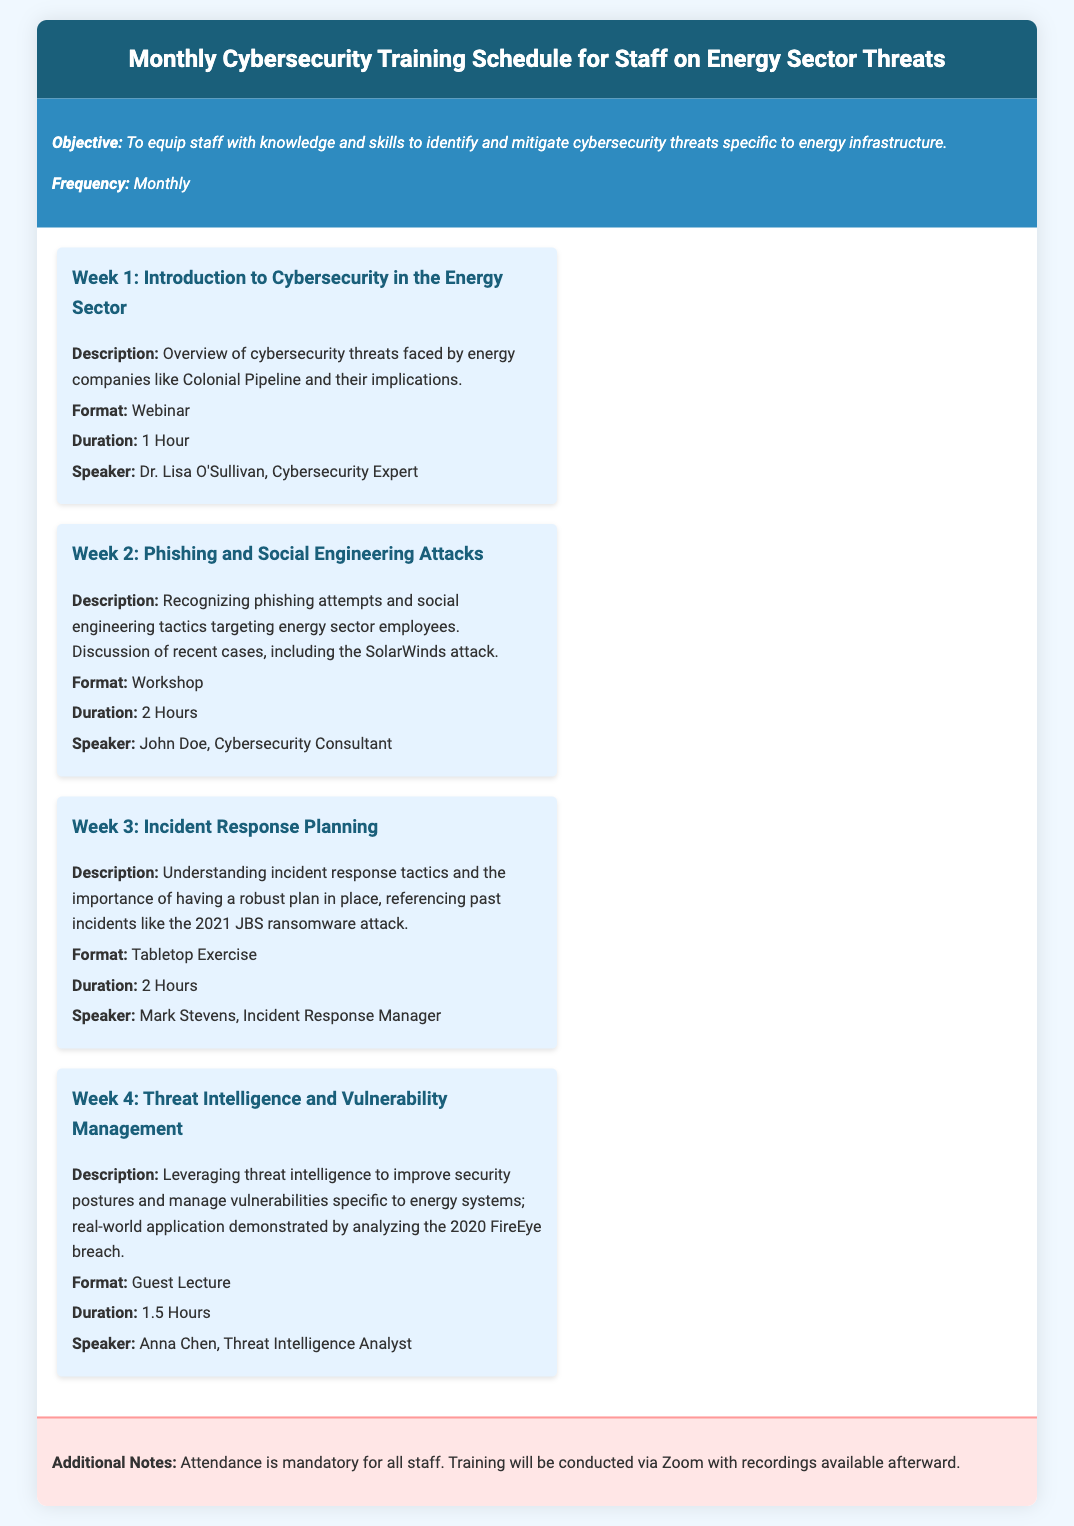What is the objective of the training? The objective of the training is stated clearly in the document, focusing on equipping staff with specific knowledge.
Answer: To equip staff with knowledge and skills to identify and mitigate cybersecurity threats specific to energy infrastructure Who is the speaker for Week 2? The document lists the speaker names for each week, specifically noting John Doe for Week 2.
Answer: John Doe What is the format of Week 3 training? The format for each weekly training session is specified, with the format for Week 3 being a Tabletop Exercise.
Answer: Tabletop Exercise How long does the Week 4 session last? The duration of each training session is provided, with Week 4 lasting 1.5 Hours.
Answer: 1.5 Hours Which attack does Week 2 reference? The document mentions specific incidents related to the topics covered, including the SolarWinds attack in relation to Week 2.
Answer: SolarWinds attack What type of session is scheduled for Week 1? The document mentions the format for each week's training, indicating that Week 1 is a Webinar.
Answer: Webinar How many hours is the total training time for the month? Summing the durations of each week's session gives a total training time for the month, which is 6.5 Hours.
Answer: 6.5 Hours Where will the training be conducted? The document specifies the platform used for the sessions, which is Zoom.
Answer: Zoom Is training attendance optional? The document provides a note regarding attendance, specifying that it is mandatory for all staff.
Answer: Mandatory 